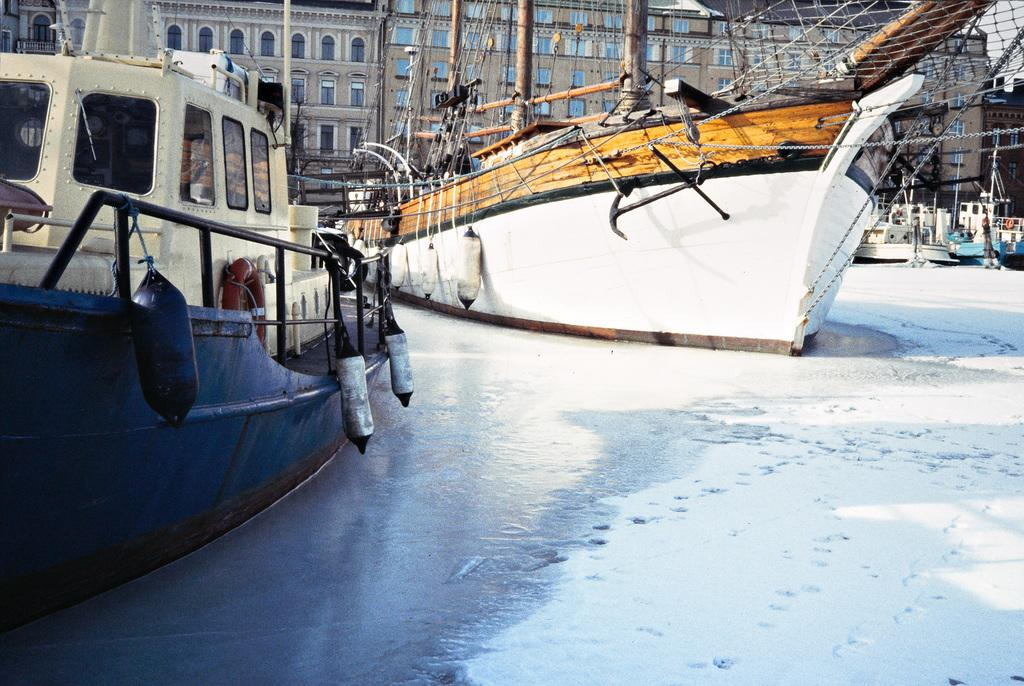What is in the water in the image? There are boats in the water in the image. What can be seen in the distance behind the boats? There are buildings and snow visible in the background. What are the ropes used for in the image? The purpose of the ropes is not specified, but they are present in the image. What other unspecified objects can be seen in the background? There are other unspecified objects in the background. What statement is being made by the leg in the image? There is no leg present in the image, so no statement can be made by it. 